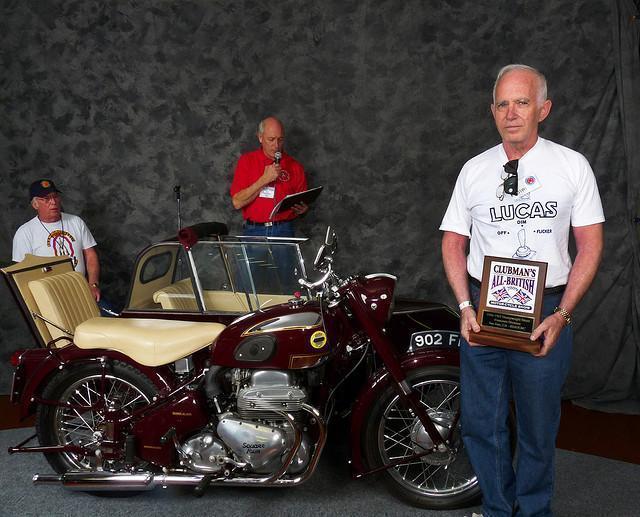Why is the man holding a microphone?
Pick the correct solution from the four options below to address the question.
Options: He's yelling, he's singing, he's crying, he's speaking. He's speaking. 